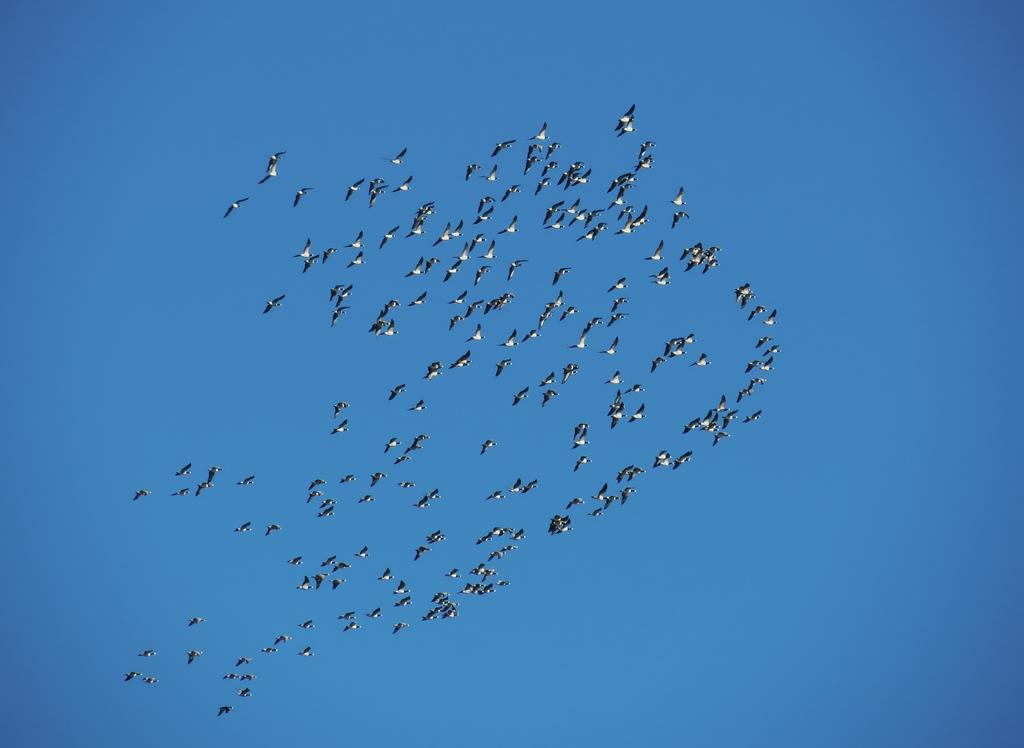What is the main subject of the image? The main subject of the image is many birds. What are the birds doing in the image? The birds are flying in the sky. What type of curve can be seen in the image? There is no curve present in the image; it features many birds flying in the sky. What kind of cord is visible in the image? There is no cord present in the image. 